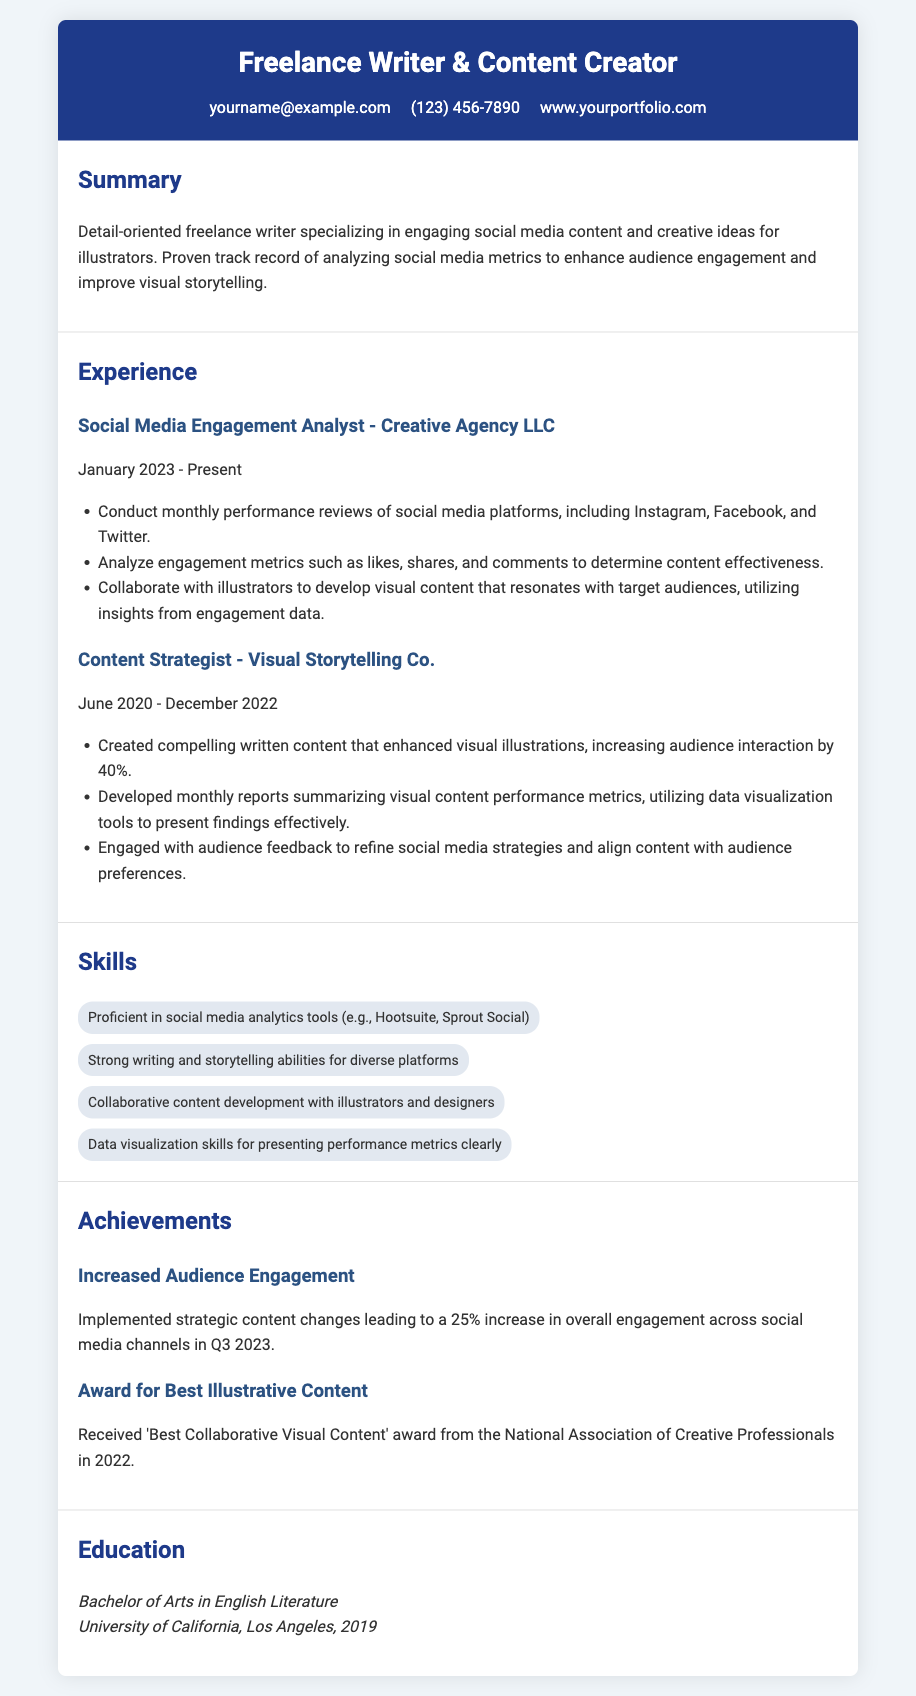what is the role of the individual in the document? The individual's role is explicitly stated in the header as "Freelance Writer & Content Creator."
Answer: Freelance Writer & Content Creator which company is mentioned as the current employer? The company's name where the individual currently works is noted under the experience section as "Creative Agency LLC."
Answer: Creative Agency LLC when did the individual start their current position? The starting date of the current position is listed as "January 2023."
Answer: January 2023 by what percentage did audience interaction increase due to written content? The document states that audience interaction increased by "40%."
Answer: 40% what award did the individual receive in 2022? The award received in 2022 is explicitly mentioned as "Best Collaborative Visual Content."
Answer: Best Collaborative Visual Content which skill is associated with data visualization? The relevant skill noted in the skills section is "Data visualization skills for presenting performance metrics clearly."
Answer: Data visualization skills how long did the individual work at Visual Storytelling Co.? The work duration at Visual Storytelling Co. is specified as "June 2020 - December 2022," which is 2 and a half years.
Answer: 2 and a half years what was the increase in overall engagement noted in Q3 2023? The document specifies a "25% increase in overall engagement across social media channels in Q3 2023."
Answer: 25% where did the individual obtain their degree? The education section lists the university as the "University of California, Los Angeles."
Answer: University of California, Los Angeles 